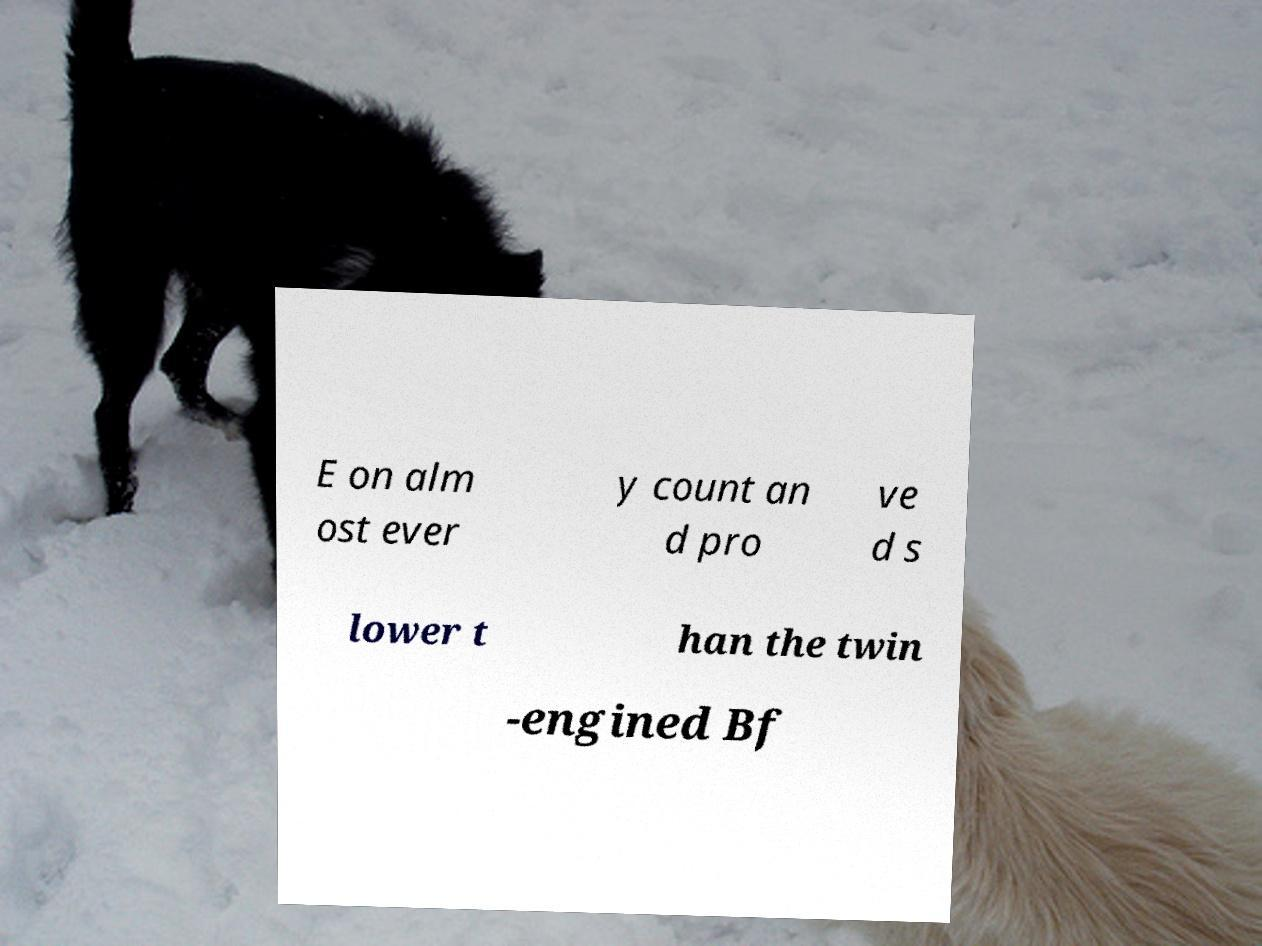There's text embedded in this image that I need extracted. Can you transcribe it verbatim? E on alm ost ever y count an d pro ve d s lower t han the twin -engined Bf 